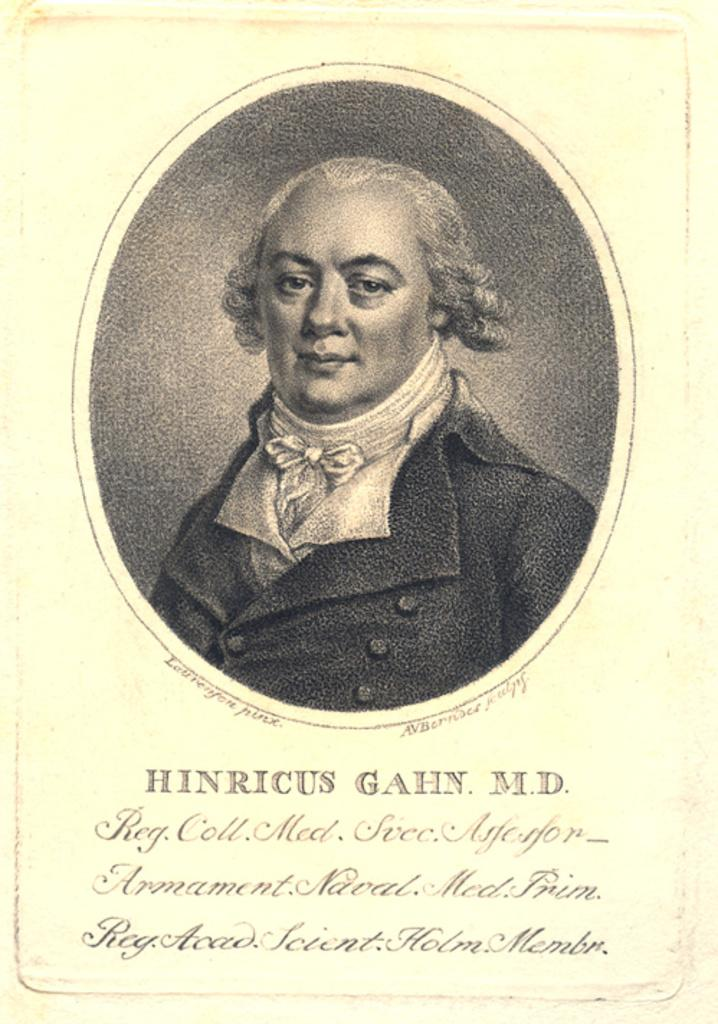What is present on the paper in the image? There is text on the paper. Can you describe the person in the image? There is one person in the image. What color is the eye of the person in the image? There is no eye visible in the image, as the person's face is not shown. 